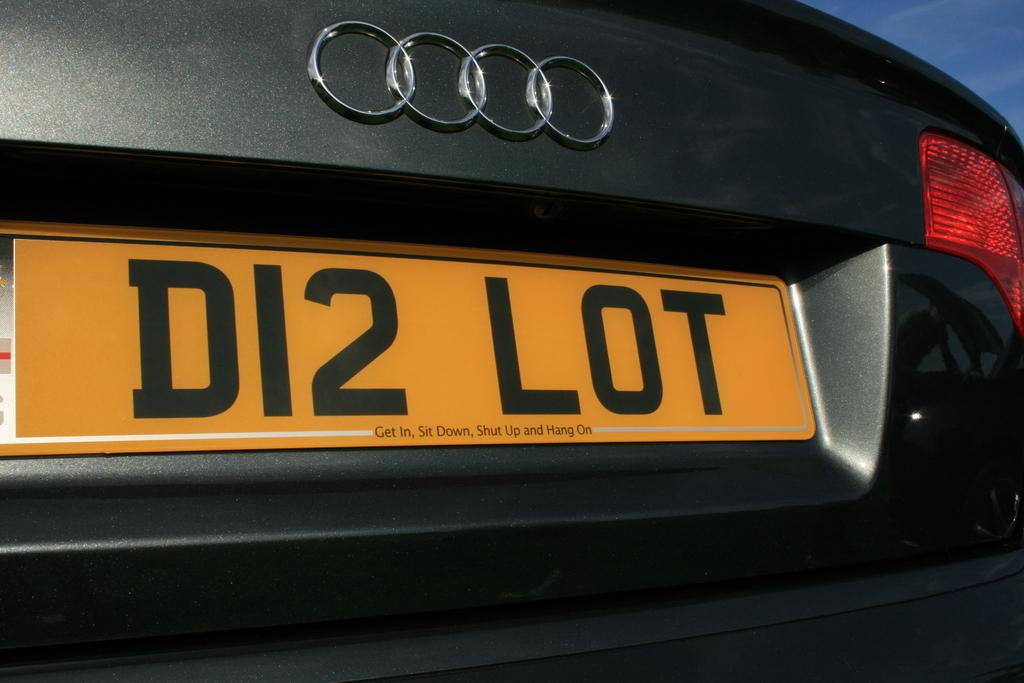<image>
Offer a succinct explanation of the picture presented. A black car has a license plate with the text D12 LOT. 